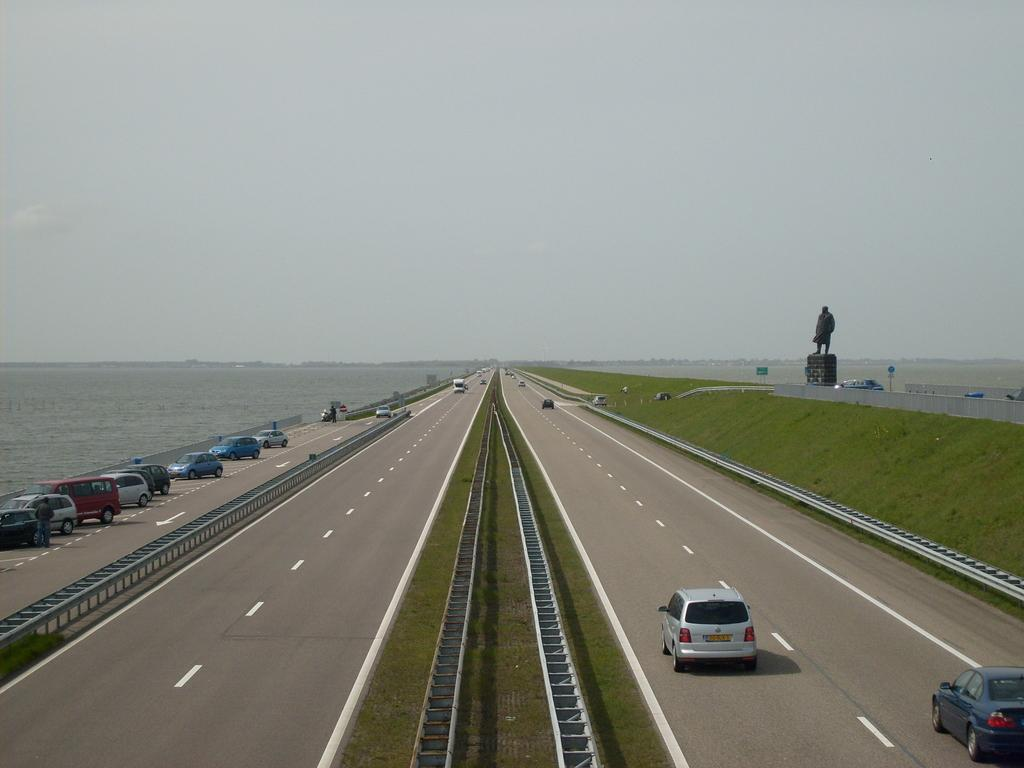What type of vegetation can be seen in the image? There is grass in the image. What else is present in the image besides grass? There is water, cars, a statue, and the sky visible at the top of the image. What type of vehicles are in the image? There are cars in the image. What is the main feature of the statue in the image? The statue is a prominent feature in the image, but its specific details are not mentioned in the facts. What is visible at the top of the image? The sky is visible at the top of the image. What type of poison is being used to water the grass in the image? There is no mention of poison or any watering activity in the image. How many quarters are visible on the statue in the image? There is no mention of quarters or any specific details about the statue in the image. 